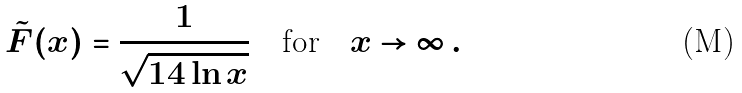Convert formula to latex. <formula><loc_0><loc_0><loc_500><loc_500>\tilde { F } ( x ) = \frac { 1 } { \sqrt { 1 4 \ln x } } \quad \text {for} \quad x \rightarrow \infty \, .</formula> 